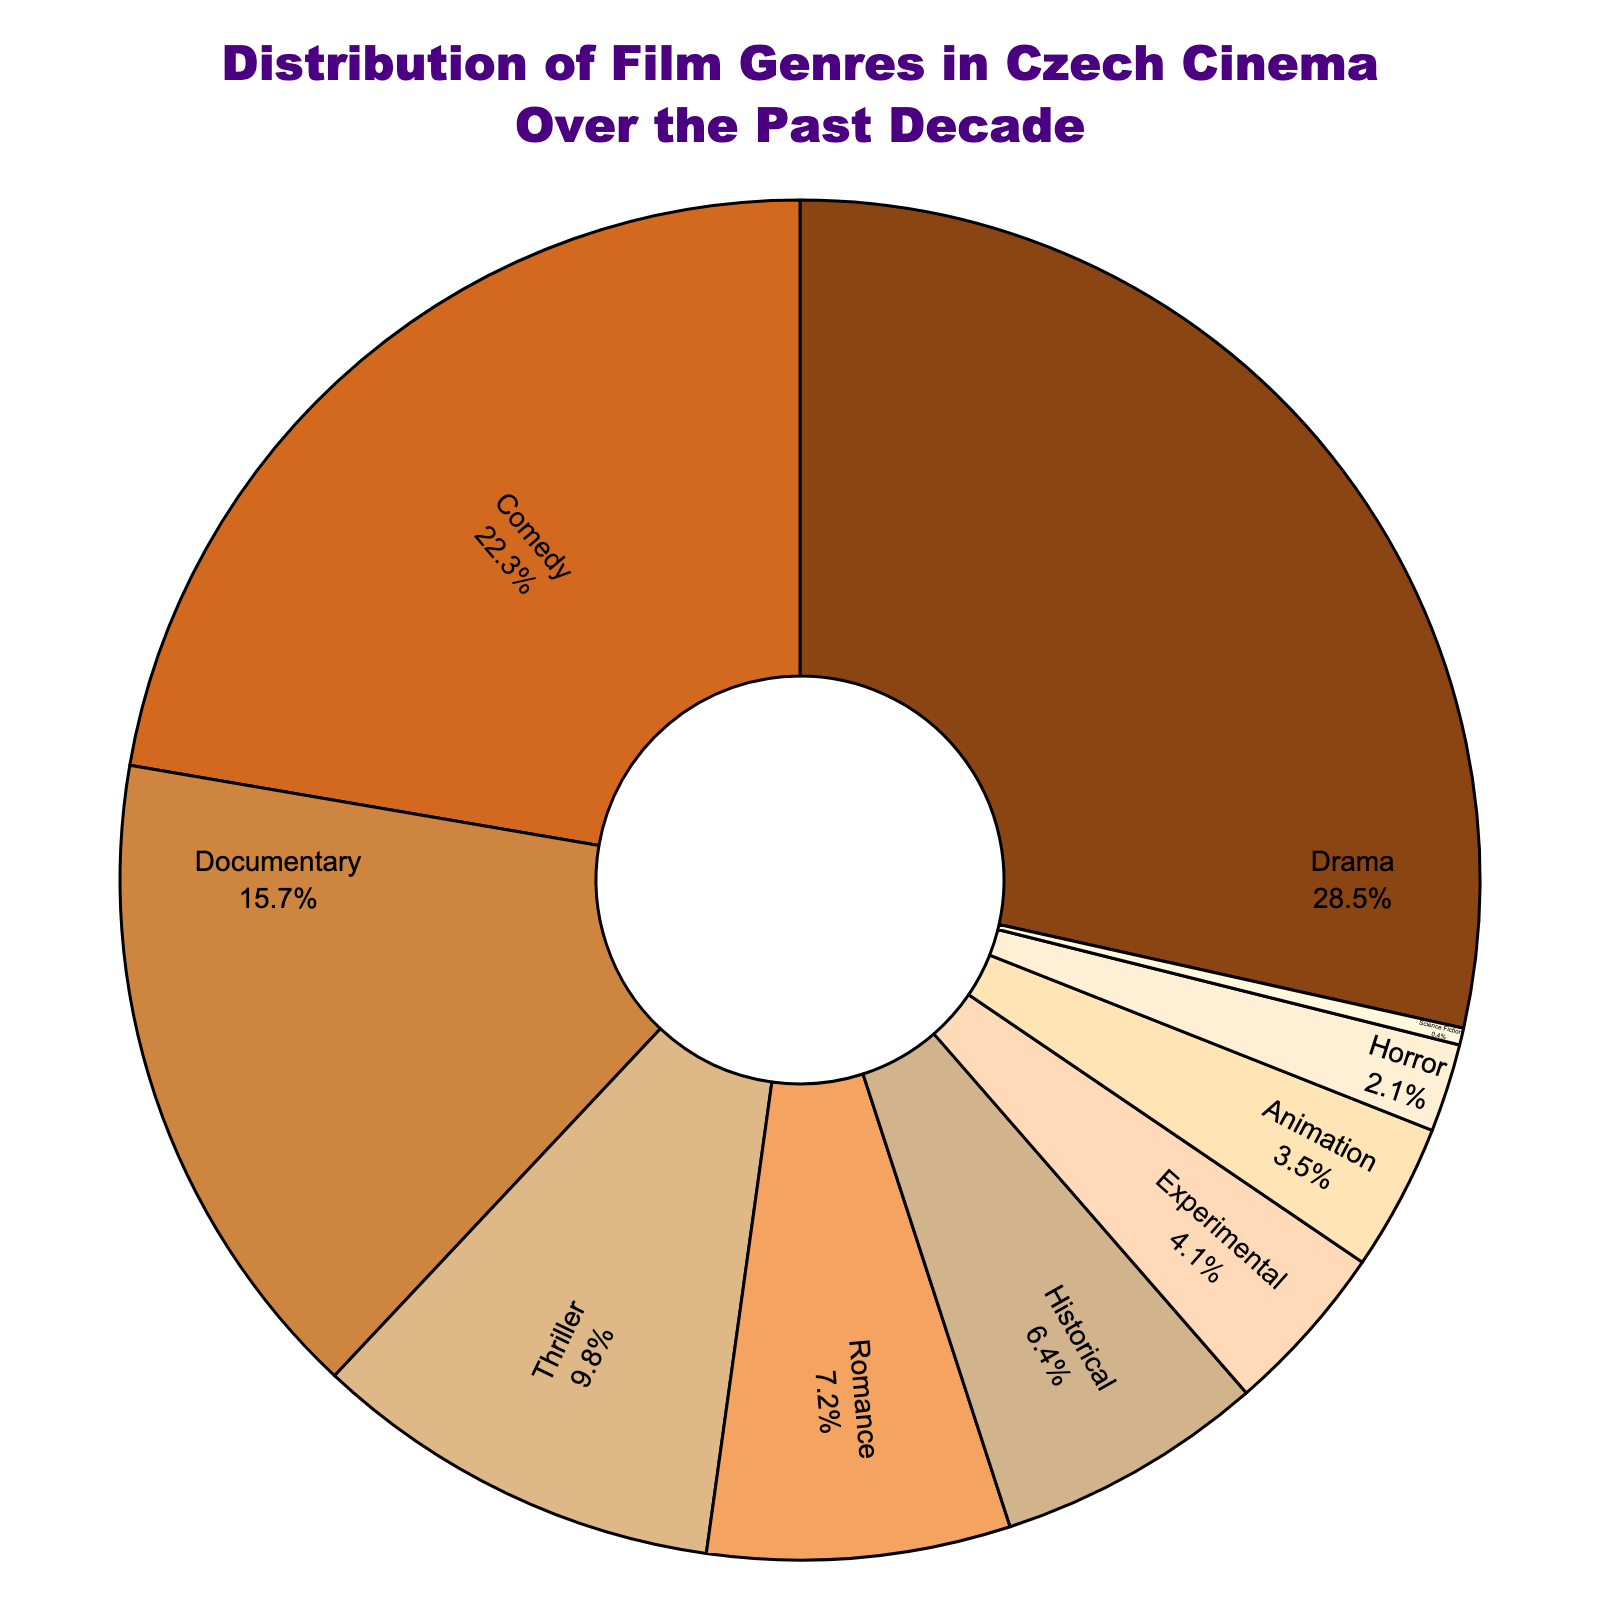What's the most common film genre in Czech cinema over the past decade? The pie chart shows the percentage distribution of various film genres, with Drama having the largest section, indicating it is the most common genre.
Answer: Drama Which genre has a higher percentage, Comedy or Documentary? By looking at the percentage values in the pie chart, we can see that Comedy (22.3%) has a higher percentage than Documentary (15.7%).
Answer: Comedy What is the combined percentage of Horror and Science Fiction genres? The percentages for Horror and Science Fiction are 2.1% and 0.4%, respectively. Adding these together sums up to 2.1 + 0.4 = 2.5%.
Answer: 2.5% Is the percentage of Animation films higher or lower than 5%? From the pie chart, the percentage of Animation films is 3.5%, which is lower than 5%.
Answer: Lower What is the difference in percentage between the Thriller and Experimental genres? Thriller has a percentage of 9.8% while Experimental has 4.1%. The difference is calculated as 9.8 - 4.1 = 5.7%.
Answer: 5.7% What is the second most common genre in the chart? The pie chart shows that Comedy, with 22.3%, is the second largest section after Drama.
Answer: Comedy What is the total percentage of less common genres (Experimental, Animation, Horror, and Science Fiction)? The percentages for Experimental (4.1%), Animation (3.5%), Horror (2.1%), and Science Fiction (0.4%) sum up to 4.1 + 3.5 + 2.1 + 0.4 = 10.1%.
Answer: 10.1% How does the percentage of Historical films compare to Romance films? Historical films hold a percentage of 6.4% while Romance films have 7.2%. Therefore, Romance films have a higher percentage than Historical films.
Answer: Romance films have a higher percentage Which genre has the smallest representative slice in the pie chart? Science Fiction has the smallest segment in the pie chart, with a percentage of 0.4%.
Answer: Science Fiction What is the combined percentage of the top three genres? The top three genres are Drama (28.5%), Comedy (22.3%), and Documentary (15.7%). The combined percentage is 28.5 + 22.3 + 15.7 = 66.5%.
Answer: 66.5% 